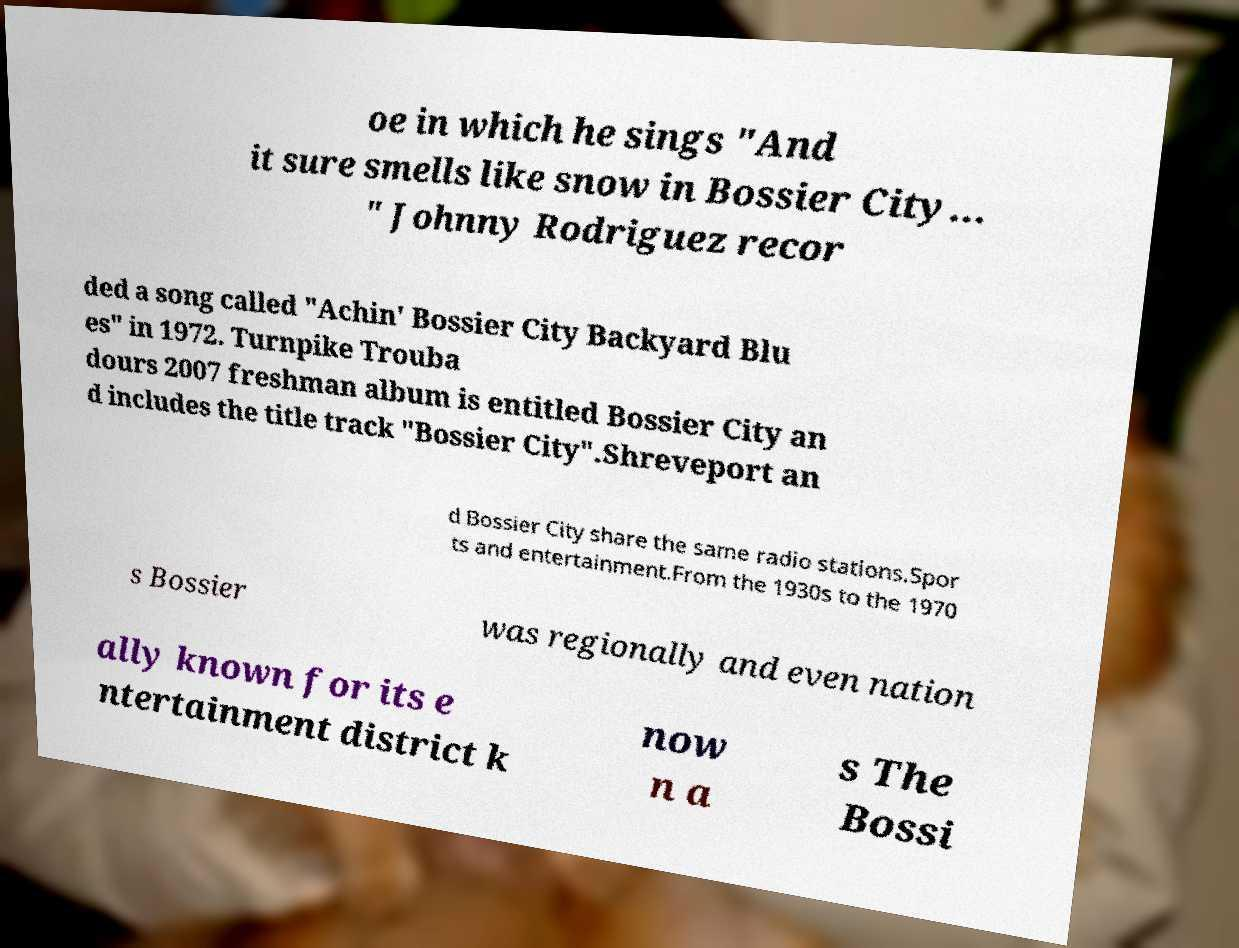Can you read and provide the text displayed in the image?This photo seems to have some interesting text. Can you extract and type it out for me? oe in which he sings "And it sure smells like snow in Bossier City... " Johnny Rodriguez recor ded a song called "Achin' Bossier City Backyard Blu es" in 1972. Turnpike Trouba dours 2007 freshman album is entitled Bossier City an d includes the title track "Bossier City".Shreveport an d Bossier City share the same radio stations.Spor ts and entertainment.From the 1930s to the 1970 s Bossier was regionally and even nation ally known for its e ntertainment district k now n a s The Bossi 